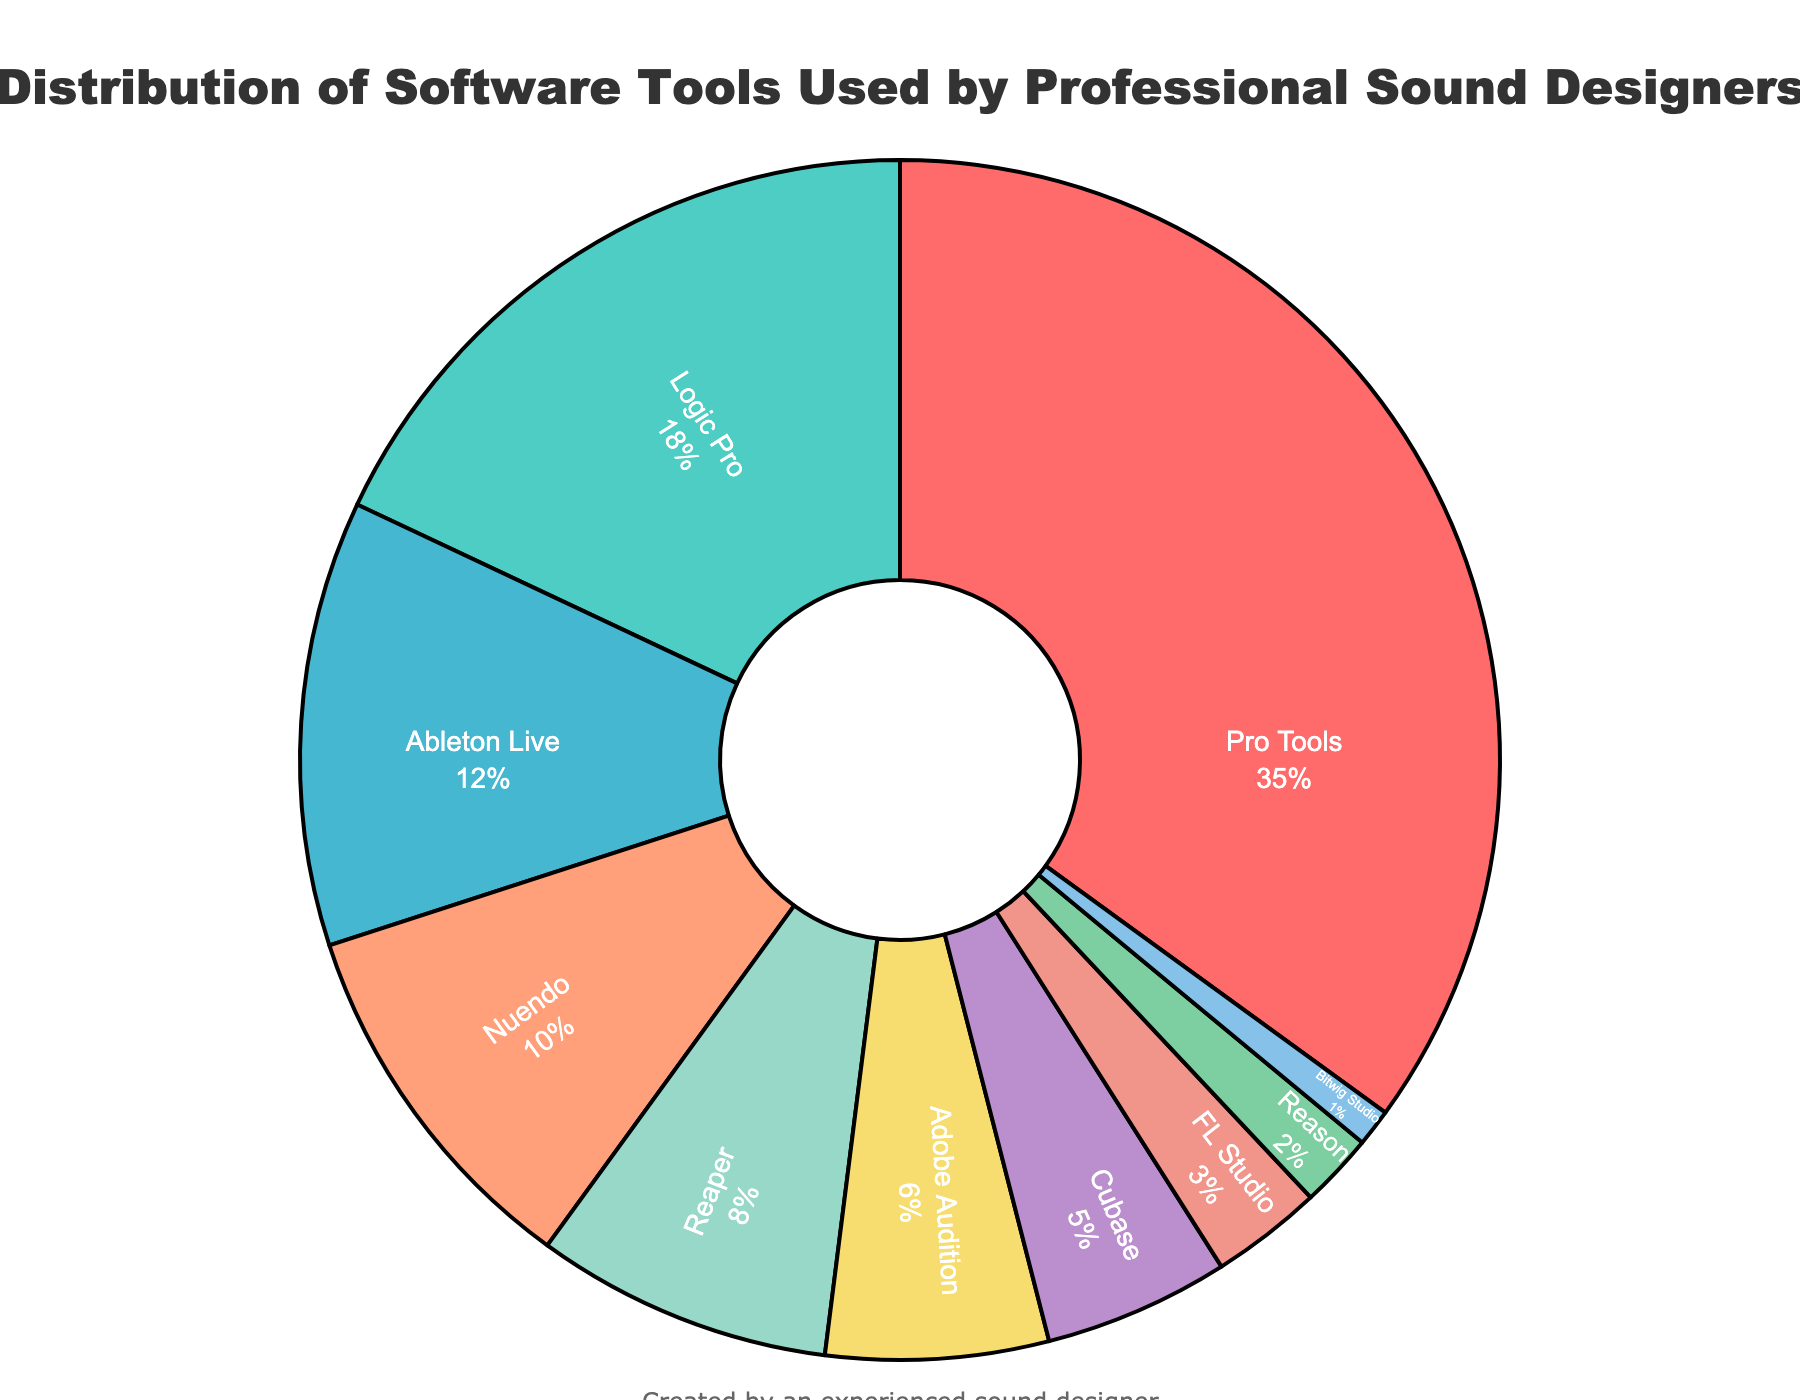What percentage of sound designers use Pro Tools? Pro Tools accounts for 35% of the total distribution, as directly indicated by the pie chart's segment for Pro Tools.
Answer: 35% Which software is used by the fewest professional sound designers? Bitwig Studio has the smallest segment in the pie chart, indicating it is used by the fewest sound designers at 1%.
Answer: Bitwig Studio What is the combined percentage of sound designers using Logic Pro and Ableton Live? Logic Pro and Ableton Live have segments representing 18% and 12% respectively. Adding these gives 18% + 12% = 30%.
Answer: 30% How does the usage of Adobe Audition compare to Reaper? The pie chart shows Reaper with 8% and Adobe Audition with 6%, so Reaper is used by more sound designers.
Answer: Reaper Which software is represented by a yellow segment on the pie chart? By visually inspecting the chart, the yellow segment corresponds to Adobe Audition, which has 6% of the total distribution.
Answer: Adobe Audition What is the difference in usage percentage between Nuendo and Cubase? The pie chart shows Nuendo at 10% and Cubase at 5%. Thus, the difference is 10% - 5% = 5%.
Answer: 5% What percentage of sound designers use software other than Pro Tools? Pro Tools is used by 35%, so the remaining percentage is 100% - 35% = 65%.
Answer: 65% Which has a larger segment, FL Studio or Reason, and by how much? FL Studio has a segment of 3% and Reason has a segment of 2%. The difference is 3% - 2% = 1%.
Answer: FL Studio by 1% How many software tools have a usage percentage of 5% or less? By counting the segments that are 5% or less: Cubase (5%), FL Studio (3%), Reason (2%), Bitwig Studio (1%) - there are 4 such software tools.
Answer: 4 